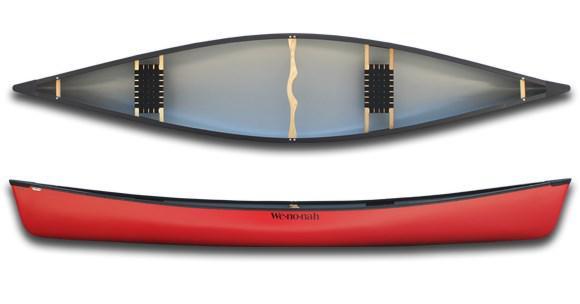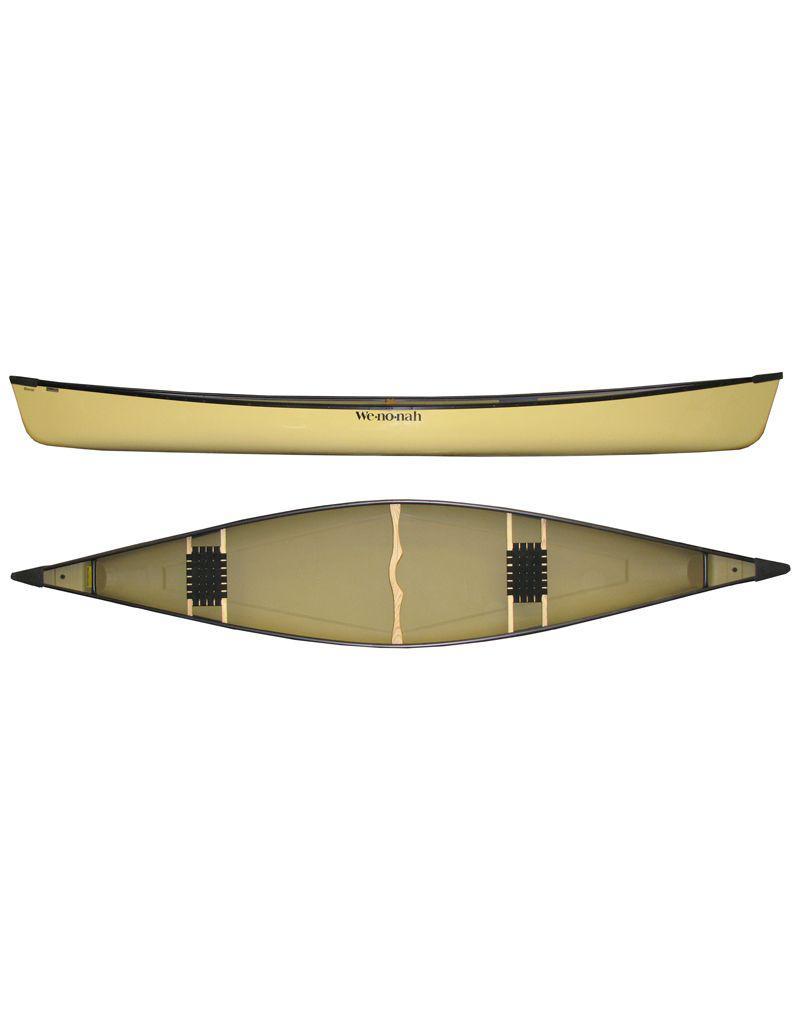The first image is the image on the left, the second image is the image on the right. Evaluate the accuracy of this statement regarding the images: "Each image features a top-viewed canoe above a side view of a canoe.". Is it true? Answer yes or no. No. The first image is the image on the left, the second image is the image on the right. Assess this claim about the two images: "There is a yellow canoe.". Correct or not? Answer yes or no. Yes. 